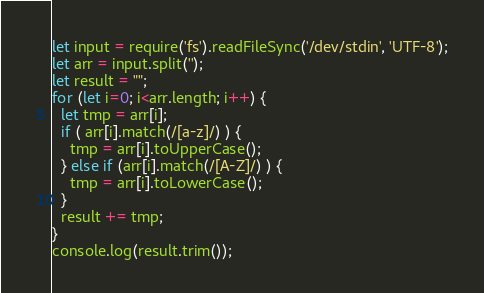<code> <loc_0><loc_0><loc_500><loc_500><_JavaScript_>let input = require('fs').readFileSync('/dev/stdin', 'UTF-8');
let arr = input.split('');
let result = "";
for (let i=0; i<arr.length; i++) {
  let tmp = arr[i];
  if ( arr[i].match(/[a-z]/) ) {
    tmp = arr[i].toUpperCase();
  } else if (arr[i].match(/[A-Z]/) ) {
    tmp = arr[i].toLowerCase();
  }
  result += tmp;
}
console.log(result.trim());
</code> 